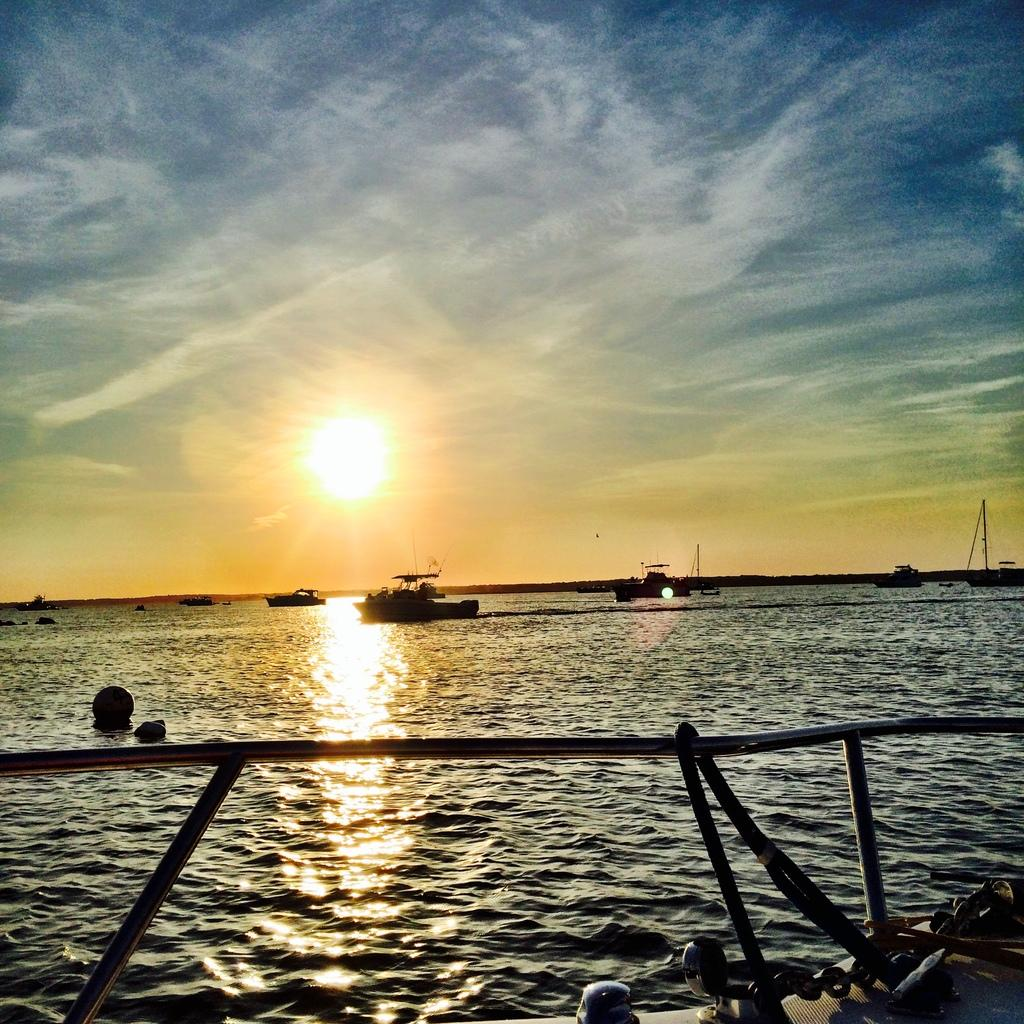What type of vehicles can be seen on the water in the image? There are boats on the surface of the water in the image. Where are the boats located in relation to the image? The boats are visible at the bottom of the image. What celestial body is present in the middle of the image? There is a sun in the middle of the image. What part of the natural environment is visible in the background of the image? The sky is visible in the background of the image. What type of story is being told by the boats in the image? There is no story being told by the boats in the image; they are simply visible on the water. Can you hear the voice of the sun in the image? There is no voice present in the image, as the sun is a celestial body and does not have a voice. 